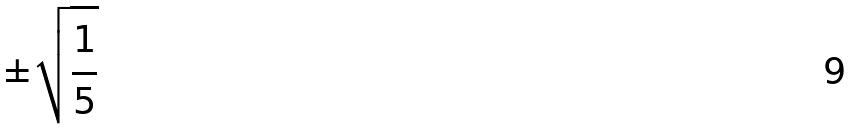Convert formula to latex. <formula><loc_0><loc_0><loc_500><loc_500>\pm \sqrt { \frac { 1 } { 5 } }</formula> 